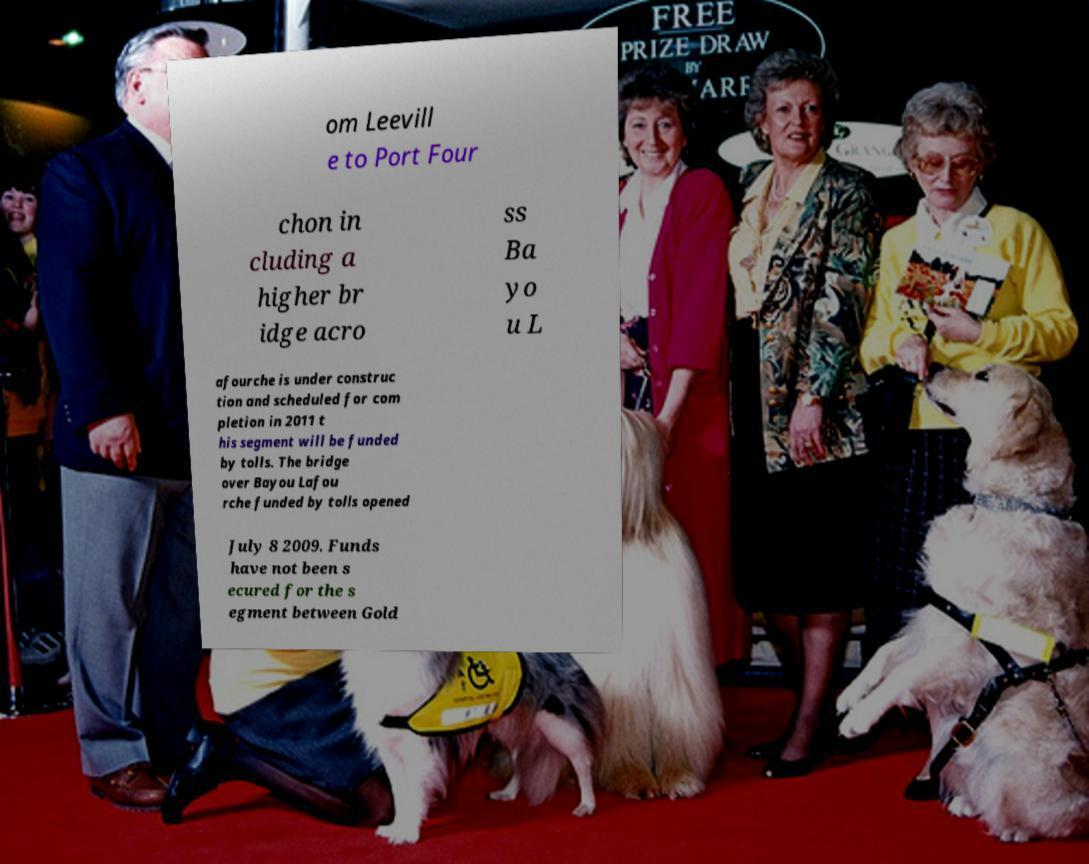I need the written content from this picture converted into text. Can you do that? om Leevill e to Port Four chon in cluding a higher br idge acro ss Ba yo u L afourche is under construc tion and scheduled for com pletion in 2011 t his segment will be funded by tolls. The bridge over Bayou Lafou rche funded by tolls opened July 8 2009. Funds have not been s ecured for the s egment between Gold 